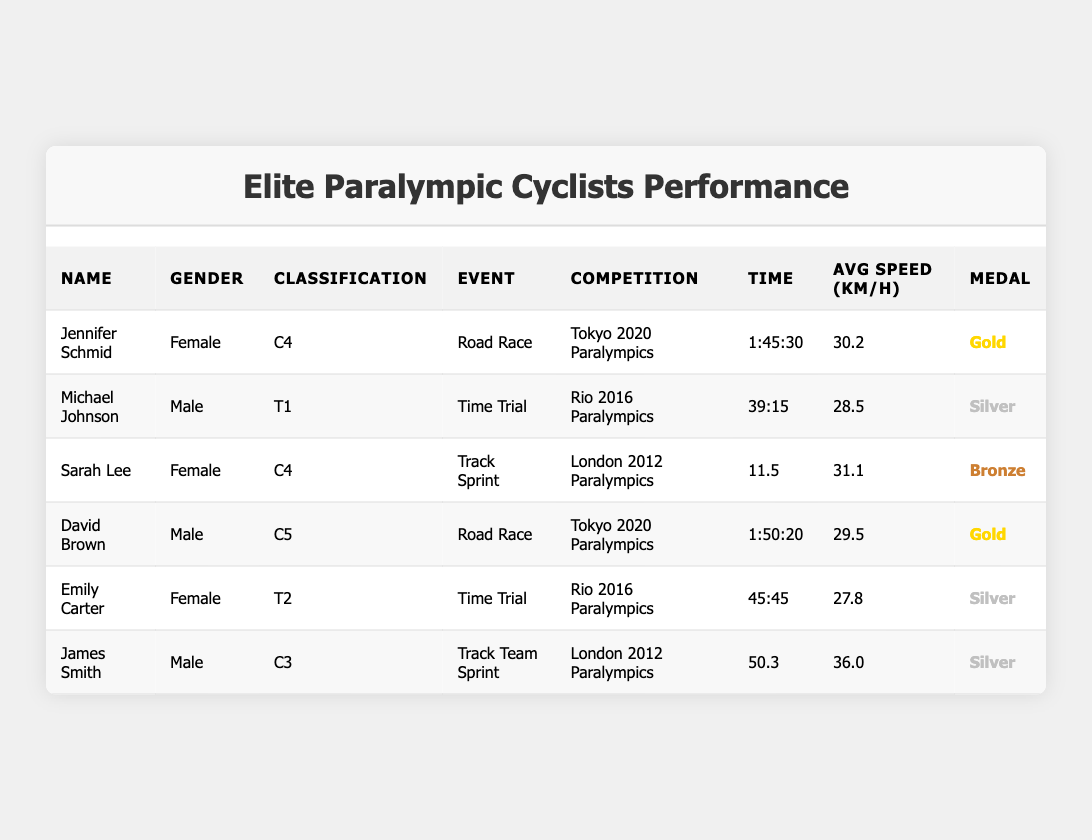What is the average speed of Jennifer Schmid in km/h? According to the table, Jennifer Schmid's average speed is listed as 30.2 km/h, which is directly retrieved from the average speed column for her performance in the Tokyo 2020 Paralympics.
Answer: 30.2 km/h How many male athletes won gold medals? The table specifies that there are two gold medals won by male athletes: David Brown from the Tokyo 2020 Paralympics and Michael Johnson from Rio 2016 Paralympics. Therefore, the answer is 1.
Answer: 1 What event did Sarah Lee compete in? The table shows Sarah Lee competed in the Track Sprint event at the London 2012 Paralympics, which is found in the event column corresponding to her name.
Answer: Track Sprint What is the total time of both road race events participated by the athletes? The times for the two road race events (Jennifer Schmid: 1:45:30 and David Brown: 1:50:20) need to be converted to a consistent unit, namely seconds. This leads to (1*3600 + 45*60 + 30) + (1*3600 + 50*60 + 20) = 6330 + 6120 = 12450 seconds. This can then be converted back to hours, minutes, and seconds as 3 hours, 27 minutes, and 30 seconds.
Answer: 3:27:30 Did any female athletes win gold medals? Looking through the medal column, it can be seen that there is only one gold medal awarded to females, which is claimed by Jennifer Schmid in the Road Race at the Tokyo 2020 Paralympics.
Answer: Yes Who had the highest average speed in the table? By comparing the average speeds listed in the table, James Smith has the highest average speed of 36.0 km/h in the Track Team Sprint event at the London 2012 Paralympics, which is the largest value seen across all performances.
Answer: 36.0 km/h Which event has the least amount of time recorded? From the table, Sarah Lee has the least time for her event, the Track Sprint, with a recorded time of 11.5 seconds, which is the shortest time listed in the time column overall.
Answer: Track Sprint How many athletes competed in time trial events? The table lists two athletes who competed in time trial events: Michael Johnson and Emily Carter. The count of these entries indicates that there were 2 athletes participating in time trials during the identified competitions.
Answer: 2 What is the average medal count per competition shown in the table? There are six athletes listed, and they represent three different competitions (Tokyo 2020, Rio 2016, and London 2012). Therefore, average medal count is 6 (total medals) divided by 3 (competitions), resulting in an average of 2 medals per competition.
Answer: 2 How many events are represented in the table? By examining the distinct event types in the table, there are four unique events listed: Road Race, Time Trial, Track Sprint, and Track Team Sprint; therefore, there are a total of 4 events represented.
Answer: 4 In which competition did the athlete with the fastest speed compete? James Smith delivered the highest average speed at 36.0 km/h in the Track Team Sprint event during the London 2012 Paralympics, so this competition is where the fastest speed was recorded.
Answer: London 2012 Paralympics 